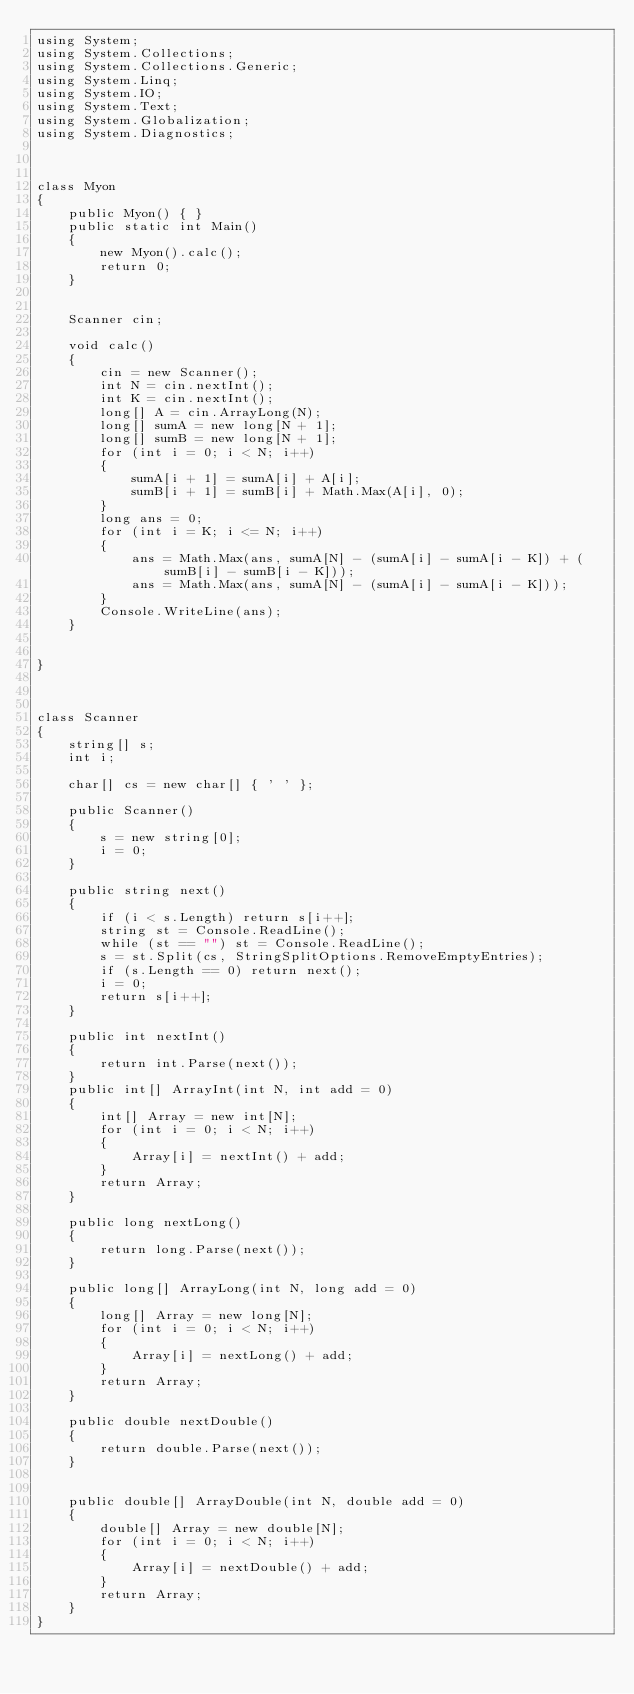<code> <loc_0><loc_0><loc_500><loc_500><_C#_>using System;
using System.Collections;
using System.Collections.Generic;
using System.Linq;
using System.IO;
using System.Text;
using System.Globalization;
using System.Diagnostics;



class Myon
{
    public Myon() { }
    public static int Main()
    {
        new Myon().calc();
        return 0;
    }


    Scanner cin;

    void calc()
    {
        cin = new Scanner();
        int N = cin.nextInt();
        int K = cin.nextInt();
        long[] A = cin.ArrayLong(N);
        long[] sumA = new long[N + 1];
        long[] sumB = new long[N + 1];
        for (int i = 0; i < N; i++)
        {
            sumA[i + 1] = sumA[i] + A[i];
            sumB[i + 1] = sumB[i] + Math.Max(A[i], 0);
        }
        long ans = 0;
        for (int i = K; i <= N; i++)
        {
            ans = Math.Max(ans, sumA[N] - (sumA[i] - sumA[i - K]) + (sumB[i] - sumB[i - K]));
            ans = Math.Max(ans, sumA[N] - (sumA[i] - sumA[i - K]));
        }
        Console.WriteLine(ans);
    }


}



class Scanner
{
    string[] s;
    int i;

    char[] cs = new char[] { ' ' };

    public Scanner()
    {
        s = new string[0];
        i = 0;
    }

    public string next()
    {
        if (i < s.Length) return s[i++];
        string st = Console.ReadLine();
        while (st == "") st = Console.ReadLine();
        s = st.Split(cs, StringSplitOptions.RemoveEmptyEntries);
        if (s.Length == 0) return next();
        i = 0;
        return s[i++];
    }

    public int nextInt()
    {
        return int.Parse(next());
    }
    public int[] ArrayInt(int N, int add = 0)
    {
        int[] Array = new int[N];
        for (int i = 0; i < N; i++)
        {
            Array[i] = nextInt() + add;
        }
        return Array;
    }

    public long nextLong()
    {
        return long.Parse(next());
    }

    public long[] ArrayLong(int N, long add = 0)
    {
        long[] Array = new long[N];
        for (int i = 0; i < N; i++)
        {
            Array[i] = nextLong() + add;
        }
        return Array;
    }

    public double nextDouble()
    {
        return double.Parse(next());
    }


    public double[] ArrayDouble(int N, double add = 0)
    {
        double[] Array = new double[N];
        for (int i = 0; i < N; i++)
        {
            Array[i] = nextDouble() + add;
        }
        return Array;
    }
}
</code> 